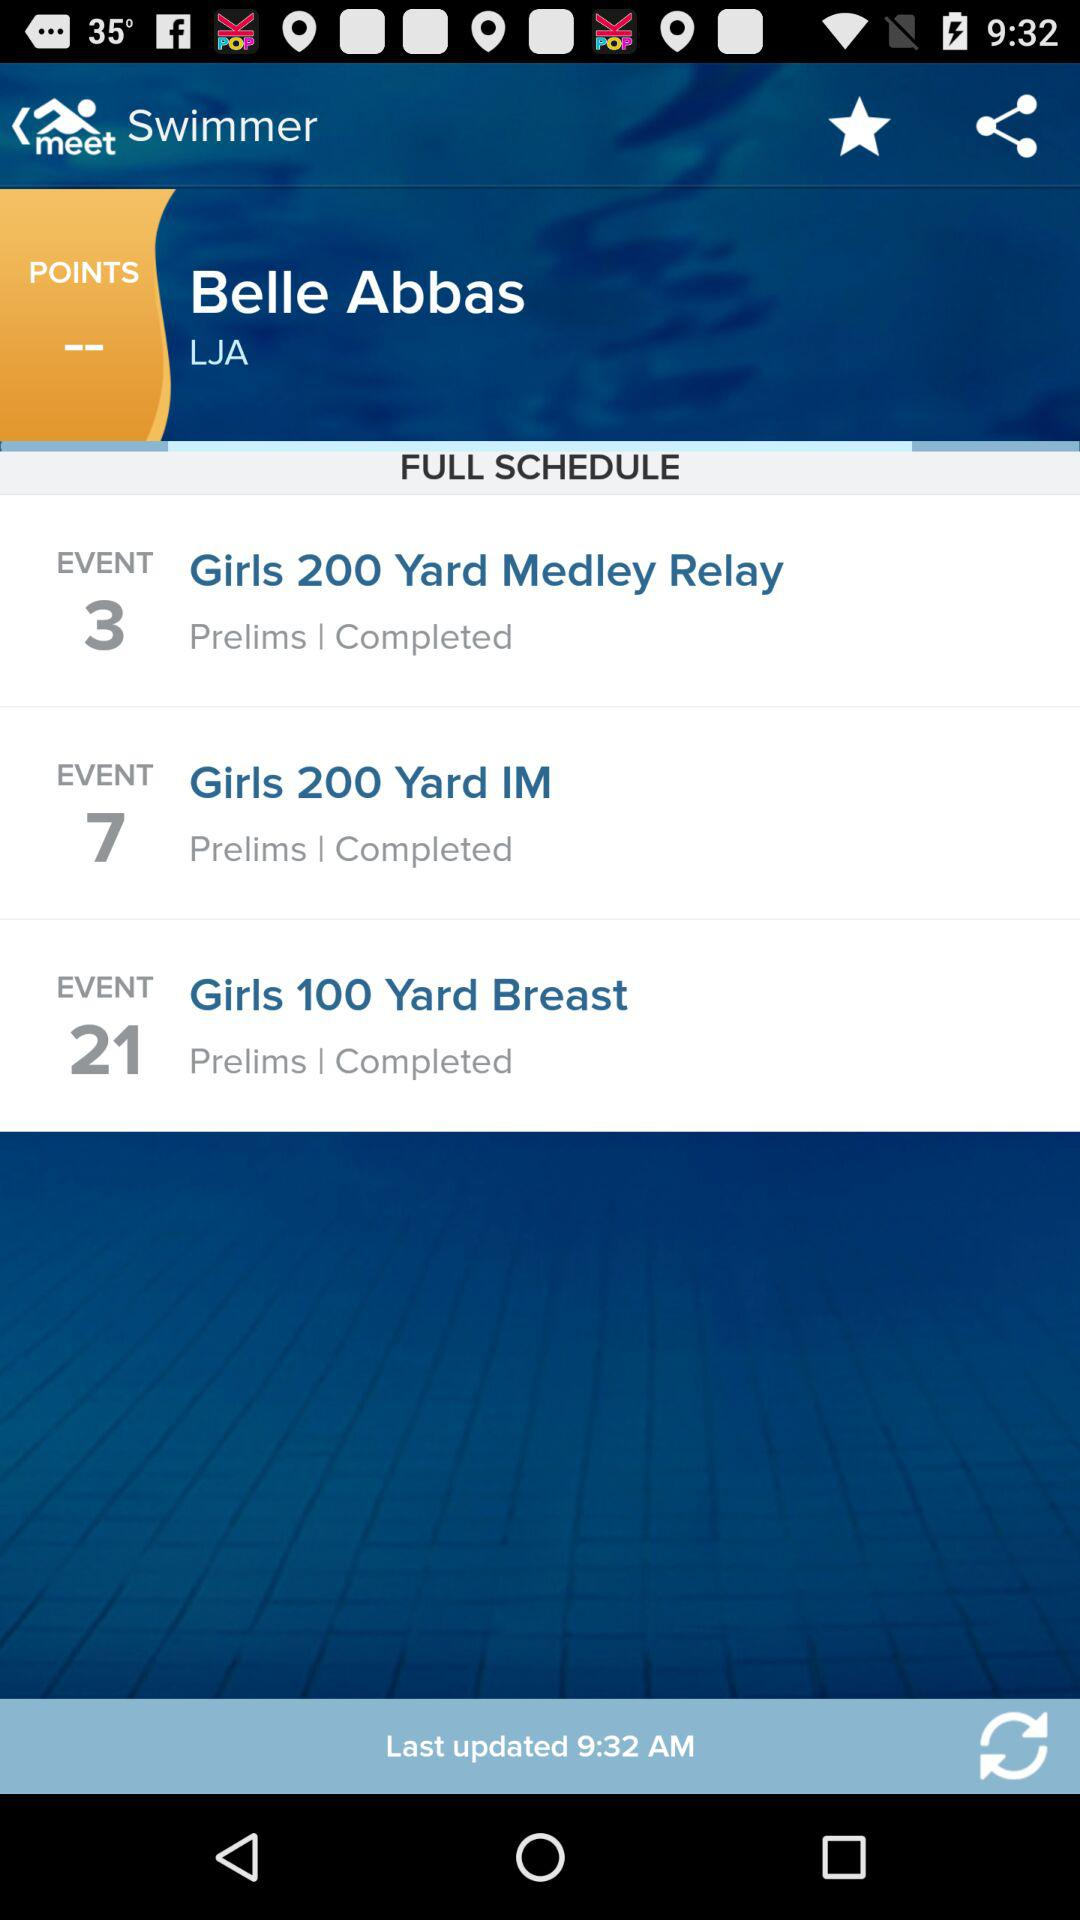What is the status of "Girls 100 Yard Breast"? The status of "Girls 100 Yard Breast" is "Completed". 